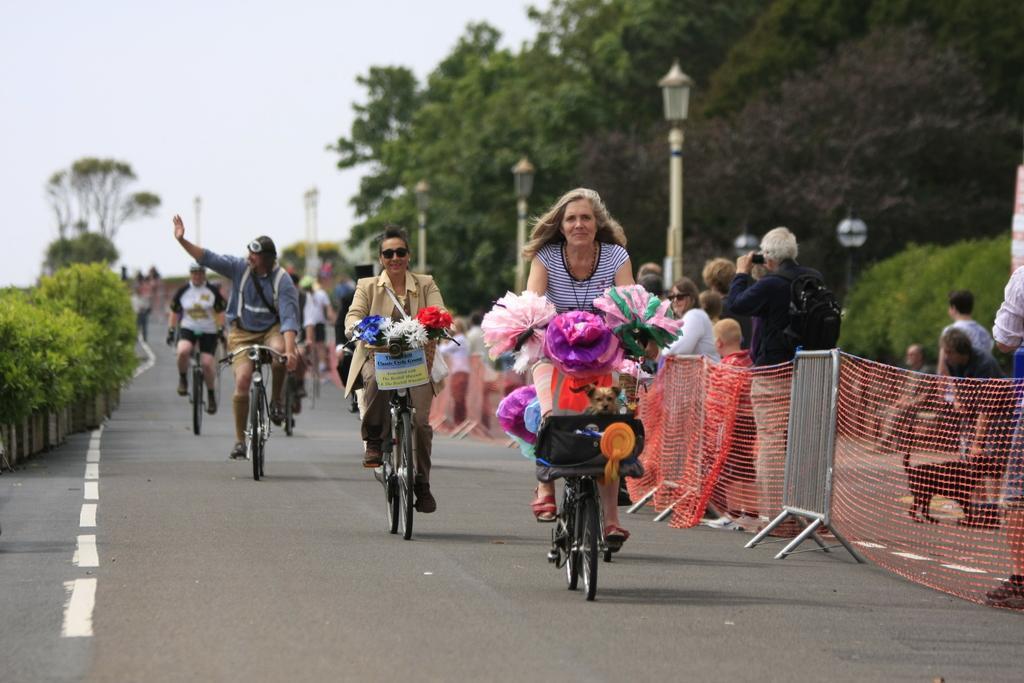Can you describe this image briefly? this picture shows a group of people riding bicycles and we see few decorative papers in front of the bicycle few trees on the side and few people are standing on the side walk and we see a man holding a dog with the help of a string 